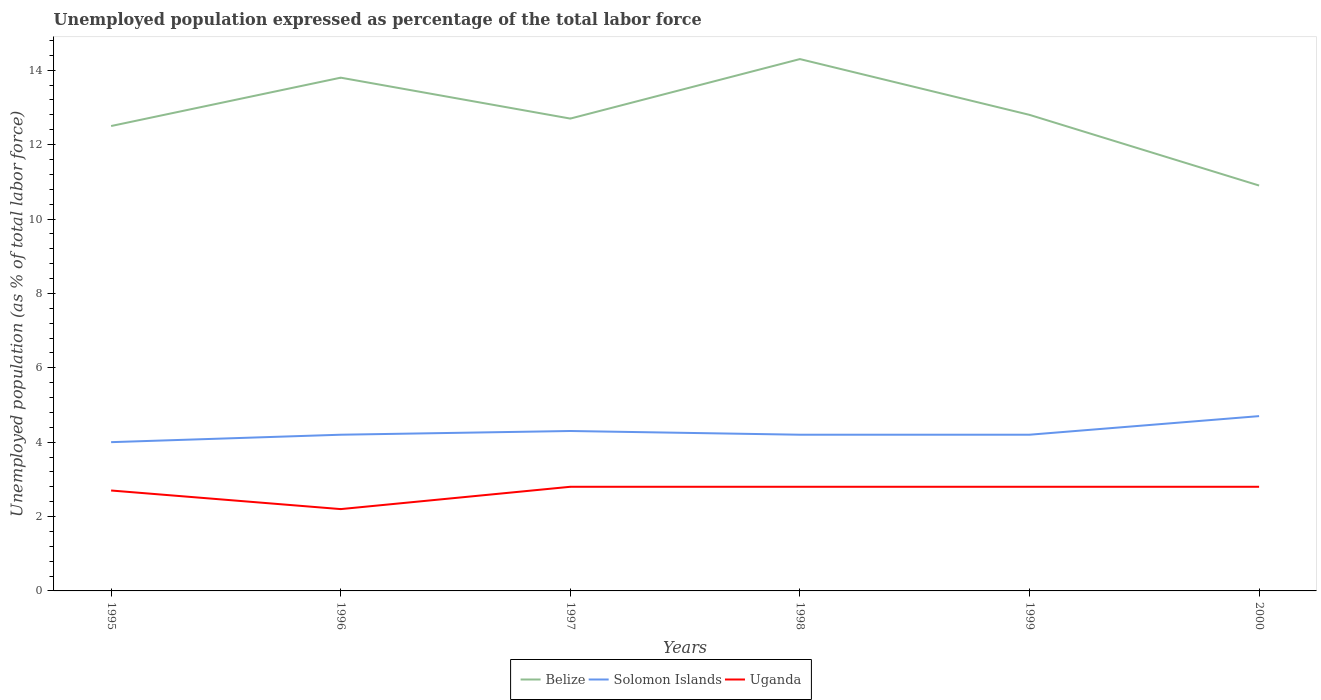Does the line corresponding to Uganda intersect with the line corresponding to Belize?
Keep it short and to the point. No. Is the number of lines equal to the number of legend labels?
Give a very brief answer. Yes. What is the total unemployment in in Belize in the graph?
Your response must be concise. -1.6. What is the difference between the highest and the second highest unemployment in in Belize?
Offer a terse response. 3.4. What is the difference between the highest and the lowest unemployment in in Belize?
Your answer should be very brief. 2. Is the unemployment in in Belize strictly greater than the unemployment in in Solomon Islands over the years?
Offer a very short reply. No. How many lines are there?
Offer a very short reply. 3. How many years are there in the graph?
Give a very brief answer. 6. What is the difference between two consecutive major ticks on the Y-axis?
Your response must be concise. 2. Are the values on the major ticks of Y-axis written in scientific E-notation?
Offer a very short reply. No. Does the graph contain grids?
Offer a terse response. No. How are the legend labels stacked?
Keep it short and to the point. Horizontal. What is the title of the graph?
Offer a very short reply. Unemployed population expressed as percentage of the total labor force. Does "Pacific island small states" appear as one of the legend labels in the graph?
Give a very brief answer. No. What is the label or title of the Y-axis?
Keep it short and to the point. Unemployed population (as % of total labor force). What is the Unemployed population (as % of total labor force) of Belize in 1995?
Provide a short and direct response. 12.5. What is the Unemployed population (as % of total labor force) in Uganda in 1995?
Offer a terse response. 2.7. What is the Unemployed population (as % of total labor force) of Belize in 1996?
Offer a very short reply. 13.8. What is the Unemployed population (as % of total labor force) of Solomon Islands in 1996?
Provide a succinct answer. 4.2. What is the Unemployed population (as % of total labor force) of Uganda in 1996?
Offer a terse response. 2.2. What is the Unemployed population (as % of total labor force) of Belize in 1997?
Keep it short and to the point. 12.7. What is the Unemployed population (as % of total labor force) of Solomon Islands in 1997?
Offer a terse response. 4.3. What is the Unemployed population (as % of total labor force) of Uganda in 1997?
Your answer should be very brief. 2.8. What is the Unemployed population (as % of total labor force) in Belize in 1998?
Provide a short and direct response. 14.3. What is the Unemployed population (as % of total labor force) of Solomon Islands in 1998?
Your answer should be very brief. 4.2. What is the Unemployed population (as % of total labor force) of Uganda in 1998?
Keep it short and to the point. 2.8. What is the Unemployed population (as % of total labor force) in Belize in 1999?
Provide a short and direct response. 12.8. What is the Unemployed population (as % of total labor force) of Solomon Islands in 1999?
Your answer should be compact. 4.2. What is the Unemployed population (as % of total labor force) of Uganda in 1999?
Provide a short and direct response. 2.8. What is the Unemployed population (as % of total labor force) of Belize in 2000?
Ensure brevity in your answer.  10.9. What is the Unemployed population (as % of total labor force) in Solomon Islands in 2000?
Your answer should be very brief. 4.7. What is the Unemployed population (as % of total labor force) of Uganda in 2000?
Your answer should be very brief. 2.8. Across all years, what is the maximum Unemployed population (as % of total labor force) of Belize?
Offer a terse response. 14.3. Across all years, what is the maximum Unemployed population (as % of total labor force) in Solomon Islands?
Make the answer very short. 4.7. Across all years, what is the maximum Unemployed population (as % of total labor force) of Uganda?
Your answer should be compact. 2.8. Across all years, what is the minimum Unemployed population (as % of total labor force) in Belize?
Your answer should be compact. 10.9. Across all years, what is the minimum Unemployed population (as % of total labor force) in Solomon Islands?
Offer a very short reply. 4. Across all years, what is the minimum Unemployed population (as % of total labor force) in Uganda?
Provide a succinct answer. 2.2. What is the total Unemployed population (as % of total labor force) of Solomon Islands in the graph?
Provide a succinct answer. 25.6. What is the difference between the Unemployed population (as % of total labor force) in Belize in 1995 and that in 1996?
Your response must be concise. -1.3. What is the difference between the Unemployed population (as % of total labor force) in Solomon Islands in 1995 and that in 1996?
Ensure brevity in your answer.  -0.2. What is the difference between the Unemployed population (as % of total labor force) in Solomon Islands in 1995 and that in 1997?
Your answer should be very brief. -0.3. What is the difference between the Unemployed population (as % of total labor force) in Uganda in 1995 and that in 1997?
Provide a short and direct response. -0.1. What is the difference between the Unemployed population (as % of total labor force) of Belize in 1995 and that in 1998?
Ensure brevity in your answer.  -1.8. What is the difference between the Unemployed population (as % of total labor force) in Solomon Islands in 1995 and that in 1998?
Make the answer very short. -0.2. What is the difference between the Unemployed population (as % of total labor force) in Solomon Islands in 1995 and that in 1999?
Your response must be concise. -0.2. What is the difference between the Unemployed population (as % of total labor force) in Uganda in 1995 and that in 1999?
Your answer should be very brief. -0.1. What is the difference between the Unemployed population (as % of total labor force) of Solomon Islands in 1995 and that in 2000?
Keep it short and to the point. -0.7. What is the difference between the Unemployed population (as % of total labor force) of Solomon Islands in 1996 and that in 1997?
Keep it short and to the point. -0.1. What is the difference between the Unemployed population (as % of total labor force) in Uganda in 1996 and that in 1997?
Make the answer very short. -0.6. What is the difference between the Unemployed population (as % of total labor force) in Solomon Islands in 1996 and that in 1998?
Offer a very short reply. 0. What is the difference between the Unemployed population (as % of total labor force) in Uganda in 1996 and that in 1999?
Provide a short and direct response. -0.6. What is the difference between the Unemployed population (as % of total labor force) in Belize in 1997 and that in 1998?
Provide a succinct answer. -1.6. What is the difference between the Unemployed population (as % of total labor force) of Solomon Islands in 1997 and that in 1998?
Provide a short and direct response. 0.1. What is the difference between the Unemployed population (as % of total labor force) in Belize in 1997 and that in 1999?
Your answer should be compact. -0.1. What is the difference between the Unemployed population (as % of total labor force) in Belize in 1997 and that in 2000?
Offer a very short reply. 1.8. What is the difference between the Unemployed population (as % of total labor force) of Solomon Islands in 1997 and that in 2000?
Provide a short and direct response. -0.4. What is the difference between the Unemployed population (as % of total labor force) of Uganda in 1997 and that in 2000?
Your response must be concise. 0. What is the difference between the Unemployed population (as % of total labor force) in Belize in 1998 and that in 1999?
Offer a very short reply. 1.5. What is the difference between the Unemployed population (as % of total labor force) of Solomon Islands in 1998 and that in 2000?
Make the answer very short. -0.5. What is the difference between the Unemployed population (as % of total labor force) in Belize in 1999 and that in 2000?
Your response must be concise. 1.9. What is the difference between the Unemployed population (as % of total labor force) of Solomon Islands in 1999 and that in 2000?
Make the answer very short. -0.5. What is the difference between the Unemployed population (as % of total labor force) of Belize in 1995 and the Unemployed population (as % of total labor force) of Solomon Islands in 1996?
Give a very brief answer. 8.3. What is the difference between the Unemployed population (as % of total labor force) of Belize in 1995 and the Unemployed population (as % of total labor force) of Uganda in 1996?
Provide a succinct answer. 10.3. What is the difference between the Unemployed population (as % of total labor force) in Belize in 1995 and the Unemployed population (as % of total labor force) in Solomon Islands in 1997?
Provide a succinct answer. 8.2. What is the difference between the Unemployed population (as % of total labor force) in Belize in 1995 and the Unemployed population (as % of total labor force) in Uganda in 1998?
Offer a terse response. 9.7. What is the difference between the Unemployed population (as % of total labor force) of Solomon Islands in 1995 and the Unemployed population (as % of total labor force) of Uganda in 1998?
Ensure brevity in your answer.  1.2. What is the difference between the Unemployed population (as % of total labor force) in Belize in 1995 and the Unemployed population (as % of total labor force) in Uganda in 1999?
Give a very brief answer. 9.7. What is the difference between the Unemployed population (as % of total labor force) in Solomon Islands in 1995 and the Unemployed population (as % of total labor force) in Uganda in 1999?
Provide a succinct answer. 1.2. What is the difference between the Unemployed population (as % of total labor force) of Belize in 1996 and the Unemployed population (as % of total labor force) of Solomon Islands in 1997?
Offer a terse response. 9.5. What is the difference between the Unemployed population (as % of total labor force) in Belize in 1996 and the Unemployed population (as % of total labor force) in Solomon Islands in 1998?
Your answer should be compact. 9.6. What is the difference between the Unemployed population (as % of total labor force) in Belize in 1996 and the Unemployed population (as % of total labor force) in Uganda in 1998?
Provide a succinct answer. 11. What is the difference between the Unemployed population (as % of total labor force) of Solomon Islands in 1996 and the Unemployed population (as % of total labor force) of Uganda in 1998?
Your response must be concise. 1.4. What is the difference between the Unemployed population (as % of total labor force) in Belize in 1996 and the Unemployed population (as % of total labor force) in Solomon Islands in 1999?
Provide a short and direct response. 9.6. What is the difference between the Unemployed population (as % of total labor force) in Belize in 1996 and the Unemployed population (as % of total labor force) in Uganda in 1999?
Make the answer very short. 11. What is the difference between the Unemployed population (as % of total labor force) in Belize in 1996 and the Unemployed population (as % of total labor force) in Uganda in 2000?
Provide a succinct answer. 11. What is the difference between the Unemployed population (as % of total labor force) in Solomon Islands in 1996 and the Unemployed population (as % of total labor force) in Uganda in 2000?
Keep it short and to the point. 1.4. What is the difference between the Unemployed population (as % of total labor force) in Belize in 1997 and the Unemployed population (as % of total labor force) in Uganda in 1998?
Your response must be concise. 9.9. What is the difference between the Unemployed population (as % of total labor force) in Solomon Islands in 1997 and the Unemployed population (as % of total labor force) in Uganda in 1998?
Offer a very short reply. 1.5. What is the difference between the Unemployed population (as % of total labor force) in Belize in 1997 and the Unemployed population (as % of total labor force) in Solomon Islands in 2000?
Your answer should be very brief. 8. What is the difference between the Unemployed population (as % of total labor force) of Solomon Islands in 1997 and the Unemployed population (as % of total labor force) of Uganda in 2000?
Offer a terse response. 1.5. What is the difference between the Unemployed population (as % of total labor force) of Belize in 1998 and the Unemployed population (as % of total labor force) of Solomon Islands in 2000?
Provide a short and direct response. 9.6. What is the difference between the Unemployed population (as % of total labor force) of Belize in 1998 and the Unemployed population (as % of total labor force) of Uganda in 2000?
Your answer should be very brief. 11.5. What is the difference between the Unemployed population (as % of total labor force) of Solomon Islands in 1998 and the Unemployed population (as % of total labor force) of Uganda in 2000?
Your answer should be compact. 1.4. What is the difference between the Unemployed population (as % of total labor force) of Belize in 1999 and the Unemployed population (as % of total labor force) of Solomon Islands in 2000?
Provide a short and direct response. 8.1. What is the difference between the Unemployed population (as % of total labor force) of Solomon Islands in 1999 and the Unemployed population (as % of total labor force) of Uganda in 2000?
Give a very brief answer. 1.4. What is the average Unemployed population (as % of total labor force) in Belize per year?
Provide a succinct answer. 12.83. What is the average Unemployed population (as % of total labor force) of Solomon Islands per year?
Keep it short and to the point. 4.27. What is the average Unemployed population (as % of total labor force) of Uganda per year?
Offer a terse response. 2.68. In the year 1995, what is the difference between the Unemployed population (as % of total labor force) in Belize and Unemployed population (as % of total labor force) in Uganda?
Ensure brevity in your answer.  9.8. In the year 1995, what is the difference between the Unemployed population (as % of total labor force) in Solomon Islands and Unemployed population (as % of total labor force) in Uganda?
Keep it short and to the point. 1.3. In the year 1996, what is the difference between the Unemployed population (as % of total labor force) of Belize and Unemployed population (as % of total labor force) of Solomon Islands?
Your answer should be very brief. 9.6. In the year 1996, what is the difference between the Unemployed population (as % of total labor force) in Solomon Islands and Unemployed population (as % of total labor force) in Uganda?
Keep it short and to the point. 2. In the year 1997, what is the difference between the Unemployed population (as % of total labor force) in Belize and Unemployed population (as % of total labor force) in Solomon Islands?
Offer a terse response. 8.4. In the year 1997, what is the difference between the Unemployed population (as % of total labor force) in Solomon Islands and Unemployed population (as % of total labor force) in Uganda?
Provide a short and direct response. 1.5. In the year 1998, what is the difference between the Unemployed population (as % of total labor force) of Belize and Unemployed population (as % of total labor force) of Solomon Islands?
Ensure brevity in your answer.  10.1. In the year 1998, what is the difference between the Unemployed population (as % of total labor force) of Belize and Unemployed population (as % of total labor force) of Uganda?
Make the answer very short. 11.5. In the year 1998, what is the difference between the Unemployed population (as % of total labor force) in Solomon Islands and Unemployed population (as % of total labor force) in Uganda?
Provide a short and direct response. 1.4. In the year 1999, what is the difference between the Unemployed population (as % of total labor force) in Belize and Unemployed population (as % of total labor force) in Uganda?
Make the answer very short. 10. In the year 2000, what is the difference between the Unemployed population (as % of total labor force) in Belize and Unemployed population (as % of total labor force) in Solomon Islands?
Keep it short and to the point. 6.2. In the year 2000, what is the difference between the Unemployed population (as % of total labor force) in Belize and Unemployed population (as % of total labor force) in Uganda?
Keep it short and to the point. 8.1. What is the ratio of the Unemployed population (as % of total labor force) of Belize in 1995 to that in 1996?
Provide a succinct answer. 0.91. What is the ratio of the Unemployed population (as % of total labor force) in Solomon Islands in 1995 to that in 1996?
Your answer should be compact. 0.95. What is the ratio of the Unemployed population (as % of total labor force) in Uganda in 1995 to that in 1996?
Provide a short and direct response. 1.23. What is the ratio of the Unemployed population (as % of total labor force) in Belize in 1995 to that in 1997?
Give a very brief answer. 0.98. What is the ratio of the Unemployed population (as % of total labor force) of Solomon Islands in 1995 to that in 1997?
Offer a very short reply. 0.93. What is the ratio of the Unemployed population (as % of total labor force) of Belize in 1995 to that in 1998?
Offer a very short reply. 0.87. What is the ratio of the Unemployed population (as % of total labor force) in Uganda in 1995 to that in 1998?
Offer a terse response. 0.96. What is the ratio of the Unemployed population (as % of total labor force) in Belize in 1995 to that in 1999?
Provide a succinct answer. 0.98. What is the ratio of the Unemployed population (as % of total labor force) of Belize in 1995 to that in 2000?
Provide a succinct answer. 1.15. What is the ratio of the Unemployed population (as % of total labor force) of Solomon Islands in 1995 to that in 2000?
Your answer should be very brief. 0.85. What is the ratio of the Unemployed population (as % of total labor force) in Uganda in 1995 to that in 2000?
Make the answer very short. 0.96. What is the ratio of the Unemployed population (as % of total labor force) in Belize in 1996 to that in 1997?
Provide a succinct answer. 1.09. What is the ratio of the Unemployed population (as % of total labor force) of Solomon Islands in 1996 to that in 1997?
Offer a very short reply. 0.98. What is the ratio of the Unemployed population (as % of total labor force) of Uganda in 1996 to that in 1997?
Make the answer very short. 0.79. What is the ratio of the Unemployed population (as % of total labor force) in Belize in 1996 to that in 1998?
Offer a terse response. 0.96. What is the ratio of the Unemployed population (as % of total labor force) of Solomon Islands in 1996 to that in 1998?
Your answer should be compact. 1. What is the ratio of the Unemployed population (as % of total labor force) of Uganda in 1996 to that in 1998?
Your answer should be very brief. 0.79. What is the ratio of the Unemployed population (as % of total labor force) in Belize in 1996 to that in 1999?
Your answer should be very brief. 1.08. What is the ratio of the Unemployed population (as % of total labor force) in Uganda in 1996 to that in 1999?
Ensure brevity in your answer.  0.79. What is the ratio of the Unemployed population (as % of total labor force) of Belize in 1996 to that in 2000?
Offer a very short reply. 1.27. What is the ratio of the Unemployed population (as % of total labor force) of Solomon Islands in 1996 to that in 2000?
Your answer should be very brief. 0.89. What is the ratio of the Unemployed population (as % of total labor force) in Uganda in 1996 to that in 2000?
Your answer should be very brief. 0.79. What is the ratio of the Unemployed population (as % of total labor force) in Belize in 1997 to that in 1998?
Your answer should be compact. 0.89. What is the ratio of the Unemployed population (as % of total labor force) of Solomon Islands in 1997 to that in 1998?
Keep it short and to the point. 1.02. What is the ratio of the Unemployed population (as % of total labor force) of Uganda in 1997 to that in 1998?
Offer a very short reply. 1. What is the ratio of the Unemployed population (as % of total labor force) of Solomon Islands in 1997 to that in 1999?
Make the answer very short. 1.02. What is the ratio of the Unemployed population (as % of total labor force) of Belize in 1997 to that in 2000?
Give a very brief answer. 1.17. What is the ratio of the Unemployed population (as % of total labor force) in Solomon Islands in 1997 to that in 2000?
Offer a very short reply. 0.91. What is the ratio of the Unemployed population (as % of total labor force) in Belize in 1998 to that in 1999?
Provide a succinct answer. 1.12. What is the ratio of the Unemployed population (as % of total labor force) of Uganda in 1998 to that in 1999?
Make the answer very short. 1. What is the ratio of the Unemployed population (as % of total labor force) of Belize in 1998 to that in 2000?
Provide a short and direct response. 1.31. What is the ratio of the Unemployed population (as % of total labor force) in Solomon Islands in 1998 to that in 2000?
Provide a short and direct response. 0.89. What is the ratio of the Unemployed population (as % of total labor force) in Uganda in 1998 to that in 2000?
Give a very brief answer. 1. What is the ratio of the Unemployed population (as % of total labor force) in Belize in 1999 to that in 2000?
Provide a succinct answer. 1.17. What is the ratio of the Unemployed population (as % of total labor force) in Solomon Islands in 1999 to that in 2000?
Offer a very short reply. 0.89. What is the difference between the highest and the second highest Unemployed population (as % of total labor force) in Belize?
Your response must be concise. 0.5. What is the difference between the highest and the lowest Unemployed population (as % of total labor force) of Belize?
Your response must be concise. 3.4. What is the difference between the highest and the lowest Unemployed population (as % of total labor force) of Solomon Islands?
Your answer should be very brief. 0.7. What is the difference between the highest and the lowest Unemployed population (as % of total labor force) of Uganda?
Your response must be concise. 0.6. 